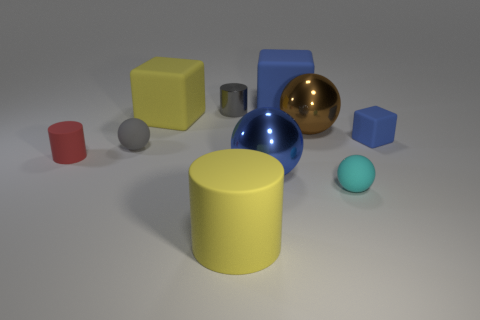Subtract all brown shiny balls. How many balls are left? 3 Subtract all blue spheres. How many spheres are left? 3 Subtract all yellow blocks. How many red cylinders are left? 1 Subtract all spheres. How many objects are left? 6 Subtract 1 blocks. How many blocks are left? 2 Subtract all brown blocks. Subtract all blue cylinders. How many blocks are left? 3 Subtract all blue metallic balls. Subtract all brown metallic objects. How many objects are left? 8 Add 1 matte cubes. How many matte cubes are left? 4 Add 1 gray blocks. How many gray blocks exist? 1 Subtract 1 brown spheres. How many objects are left? 9 